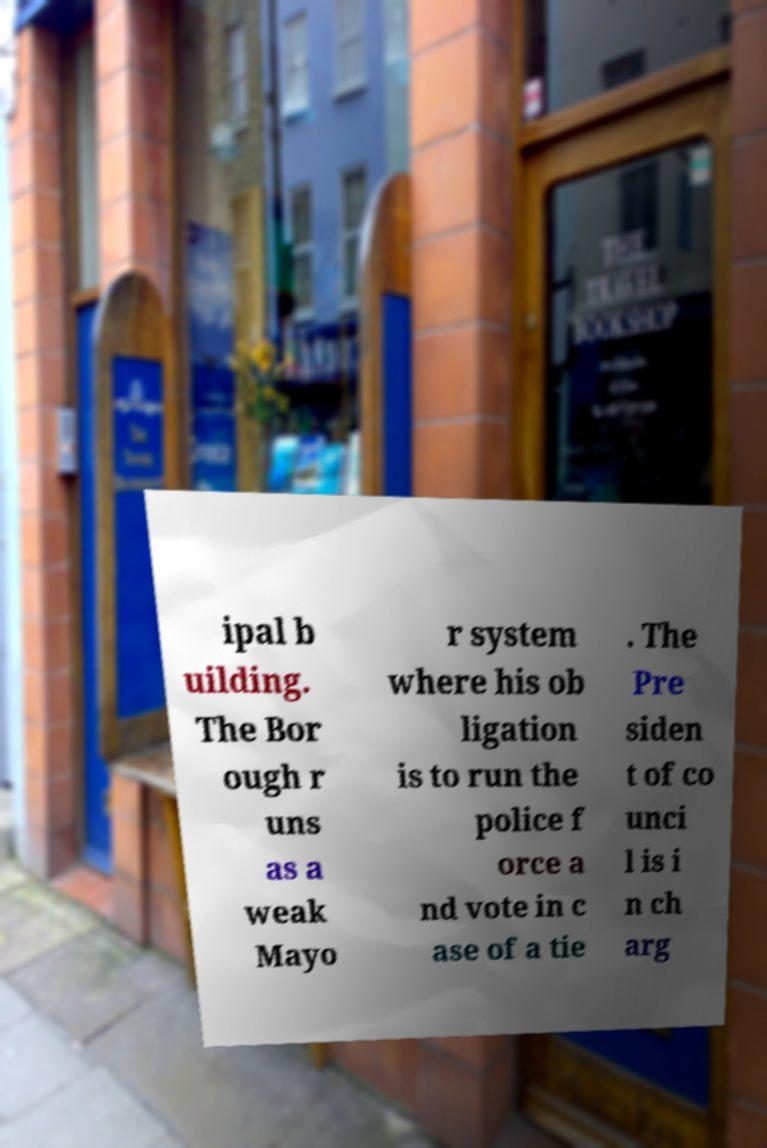Can you read and provide the text displayed in the image?This photo seems to have some interesting text. Can you extract and type it out for me? ipal b uilding. The Bor ough r uns as a weak Mayo r system where his ob ligation is to run the police f orce a nd vote in c ase of a tie . The Pre siden t of co unci l is i n ch arg 